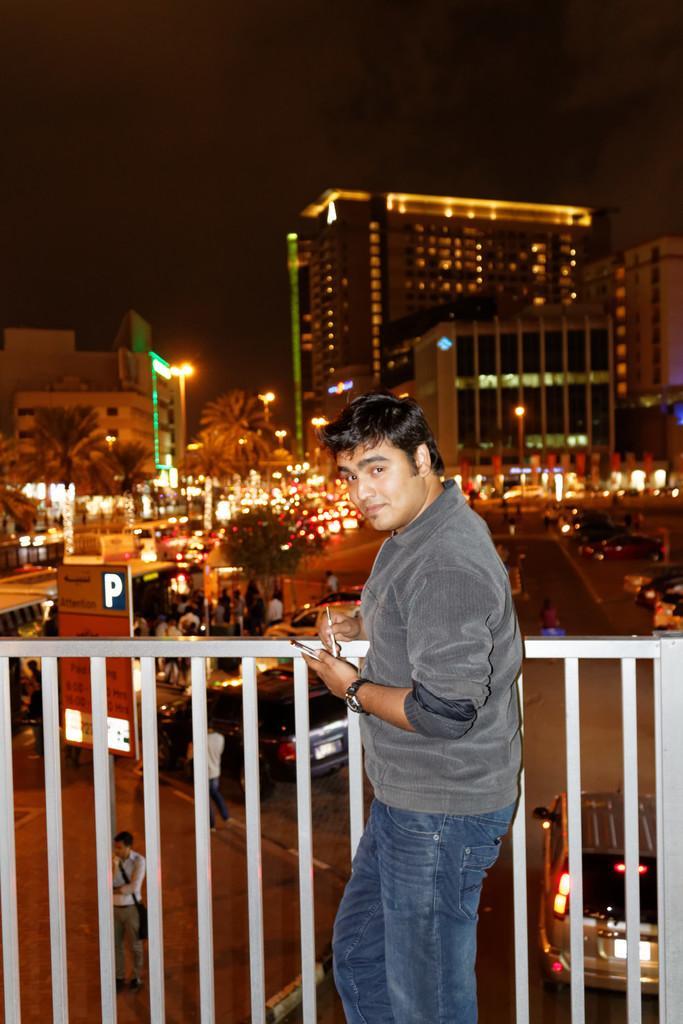How would you summarize this image in a sentence or two? In this image, there are a few people, vehicles, buildings, trees and lights. We can see the fence and the ground with some objects. We can also see a board with some text. We can see the sky. 